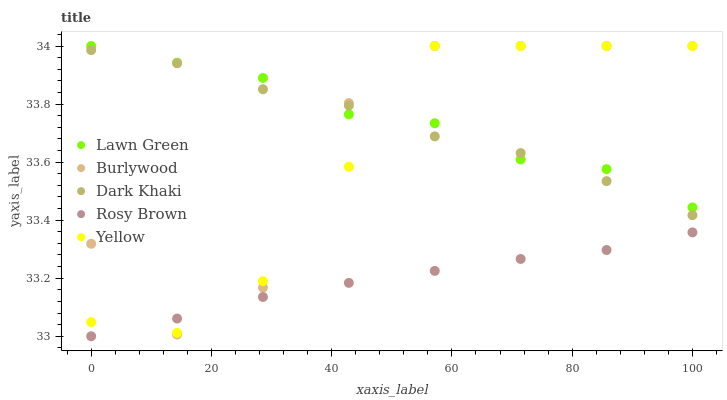Does Rosy Brown have the minimum area under the curve?
Answer yes or no. Yes. Does Lawn Green have the maximum area under the curve?
Answer yes or no. Yes. Does Lawn Green have the minimum area under the curve?
Answer yes or no. No. Does Rosy Brown have the maximum area under the curve?
Answer yes or no. No. Is Rosy Brown the smoothest?
Answer yes or no. Yes. Is Burlywood the roughest?
Answer yes or no. Yes. Is Lawn Green the smoothest?
Answer yes or no. No. Is Lawn Green the roughest?
Answer yes or no. No. Does Rosy Brown have the lowest value?
Answer yes or no. Yes. Does Lawn Green have the lowest value?
Answer yes or no. No. Does Yellow have the highest value?
Answer yes or no. Yes. Does Rosy Brown have the highest value?
Answer yes or no. No. Is Rosy Brown less than Dark Khaki?
Answer yes or no. Yes. Is Dark Khaki greater than Rosy Brown?
Answer yes or no. Yes. Does Burlywood intersect Yellow?
Answer yes or no. Yes. Is Burlywood less than Yellow?
Answer yes or no. No. Is Burlywood greater than Yellow?
Answer yes or no. No. Does Rosy Brown intersect Dark Khaki?
Answer yes or no. No. 